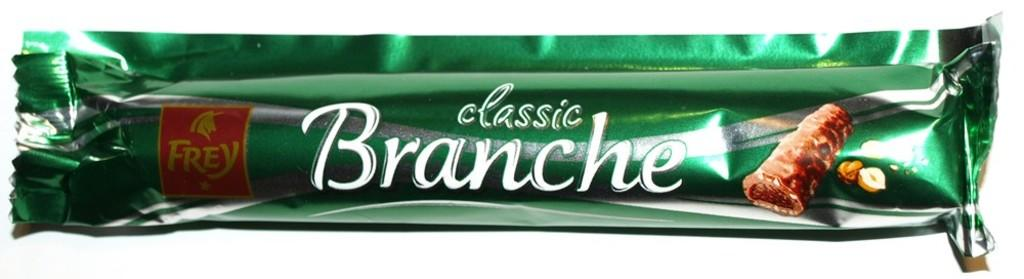<image>
Give a short and clear explanation of the subsequent image. A candy bar in a green wrapper that reads classic Branche. 